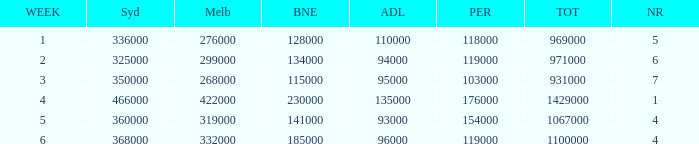What was the rating in Brisbane the week it was 276000 in Melbourne?  128000.0. 